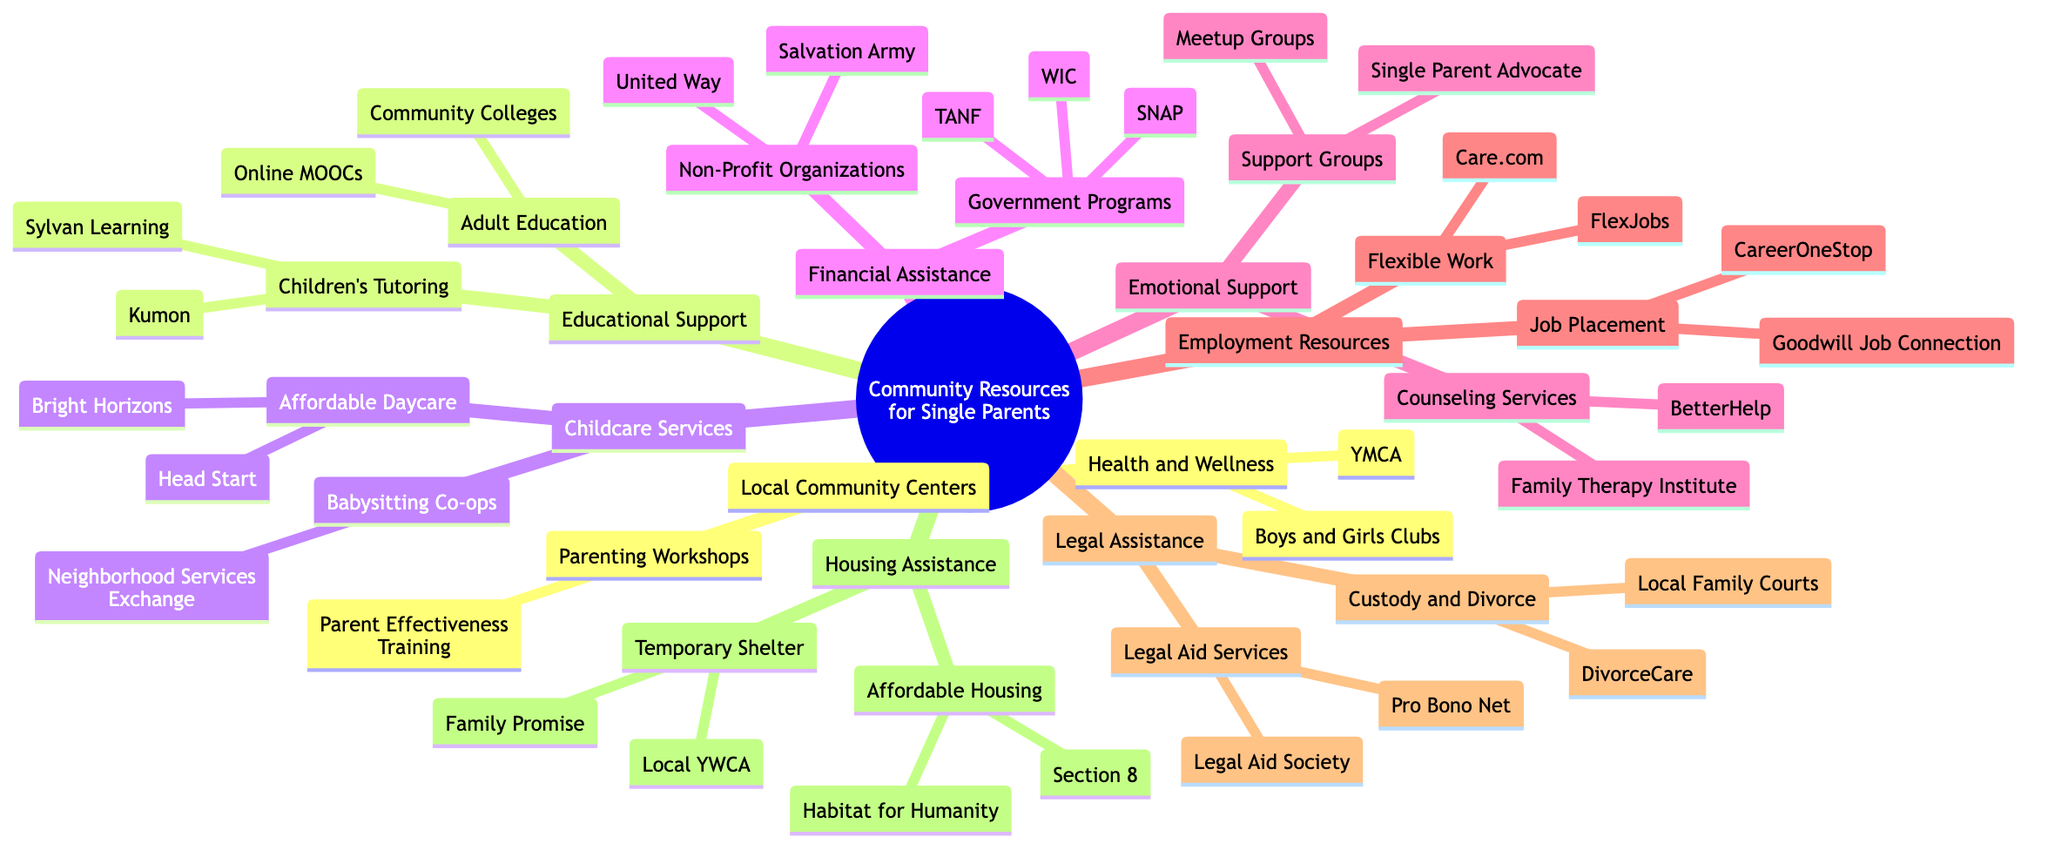What are two organizations included in the government programs for financial assistance? The diagram lists WIC and SNAP under the government programs node within financial assistance.
Answer: WIC, SNAP Which community center offers parenting workshops? The diagram specifies that Parent Effectiveness Training is categorized under parenting workshops, which is a part of local community centers.
Answer: Parent Effectiveness Training How many types of emotional support resources are listed in the diagram? The diagram shows two types of emotional support resources: counseling services and support groups.
Answer: 2 What are the names of two job placement programs mentioned in the employment resources? The job placement programs listed in the diagram are Goodwill Job Connection and CareerOneStop, found under employment resources.
Answer: Goodwill Job Connection, CareerOneStop Which service is associated with affordable housing? The diagram indicates that Section 8 is one of the services associated with affordable housing under housing assistance.
Answer: Section 8 What type of services does BetterHelp provide? BetterHelp is categorized under counseling services within the emotional support section of the diagram.
Answer: Counseling services How do childcare services help single parents according to the diagram? The diagram explains that childcare services provide affordable daycare options and babysitting co-ops, which help single parents manage childcare needs.
Answer: Affordable daycare, Babysitting co-ops What two types of educational support are provided to single parents? The diagram lists adult education classes and children's tutoring services as the two types of educational support provided.
Answer: Adult education classes, Children's tutoring services Which organization is a temporary shelter service? Family Promise is identified as a temporary shelter service under the housing assistance section of the diagram.
Answer: Family Promise 